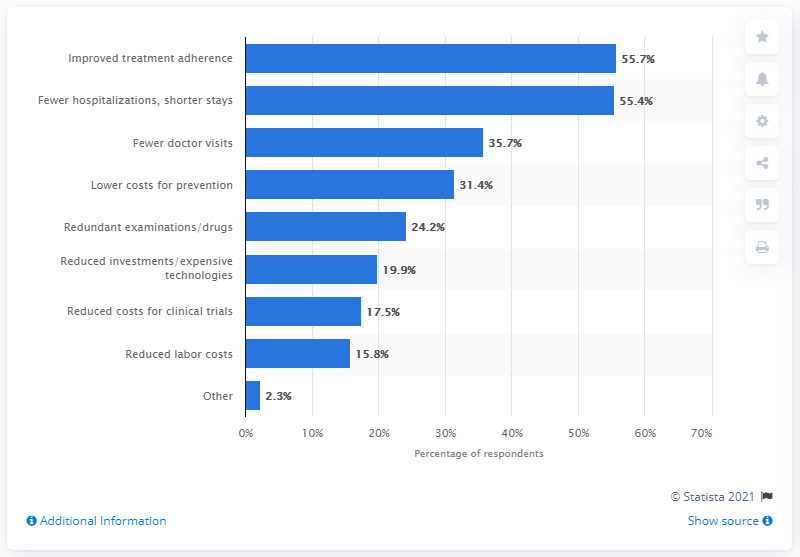What percentage of respondents stated fewer doctor visits as a potential cost saving?
 35.7 